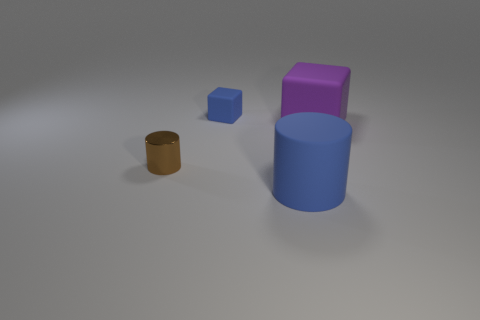What number of cylinders are the same color as the small matte block?
Give a very brief answer. 1. What number of other things are there of the same color as the tiny block?
Offer a very short reply. 1. What number of large purple blocks are behind the big purple rubber object?
Provide a succinct answer. 0. Do the cube that is in front of the blue cube and the blue matte cylinder have the same size?
Make the answer very short. Yes. What is the color of the big thing that is the same shape as the tiny matte object?
Give a very brief answer. Purple. What shape is the matte object to the right of the blue matte cylinder?
Keep it short and to the point. Cube. How many other big purple things are the same shape as the purple thing?
Your answer should be very brief. 0. Does the cylinder to the left of the big blue rubber cylinder have the same color as the block in front of the blue cube?
Your answer should be compact. No. What number of things are tiny metallic cylinders or small cyan rubber spheres?
Offer a very short reply. 1. What number of large blue things are made of the same material as the brown cylinder?
Keep it short and to the point. 0. 